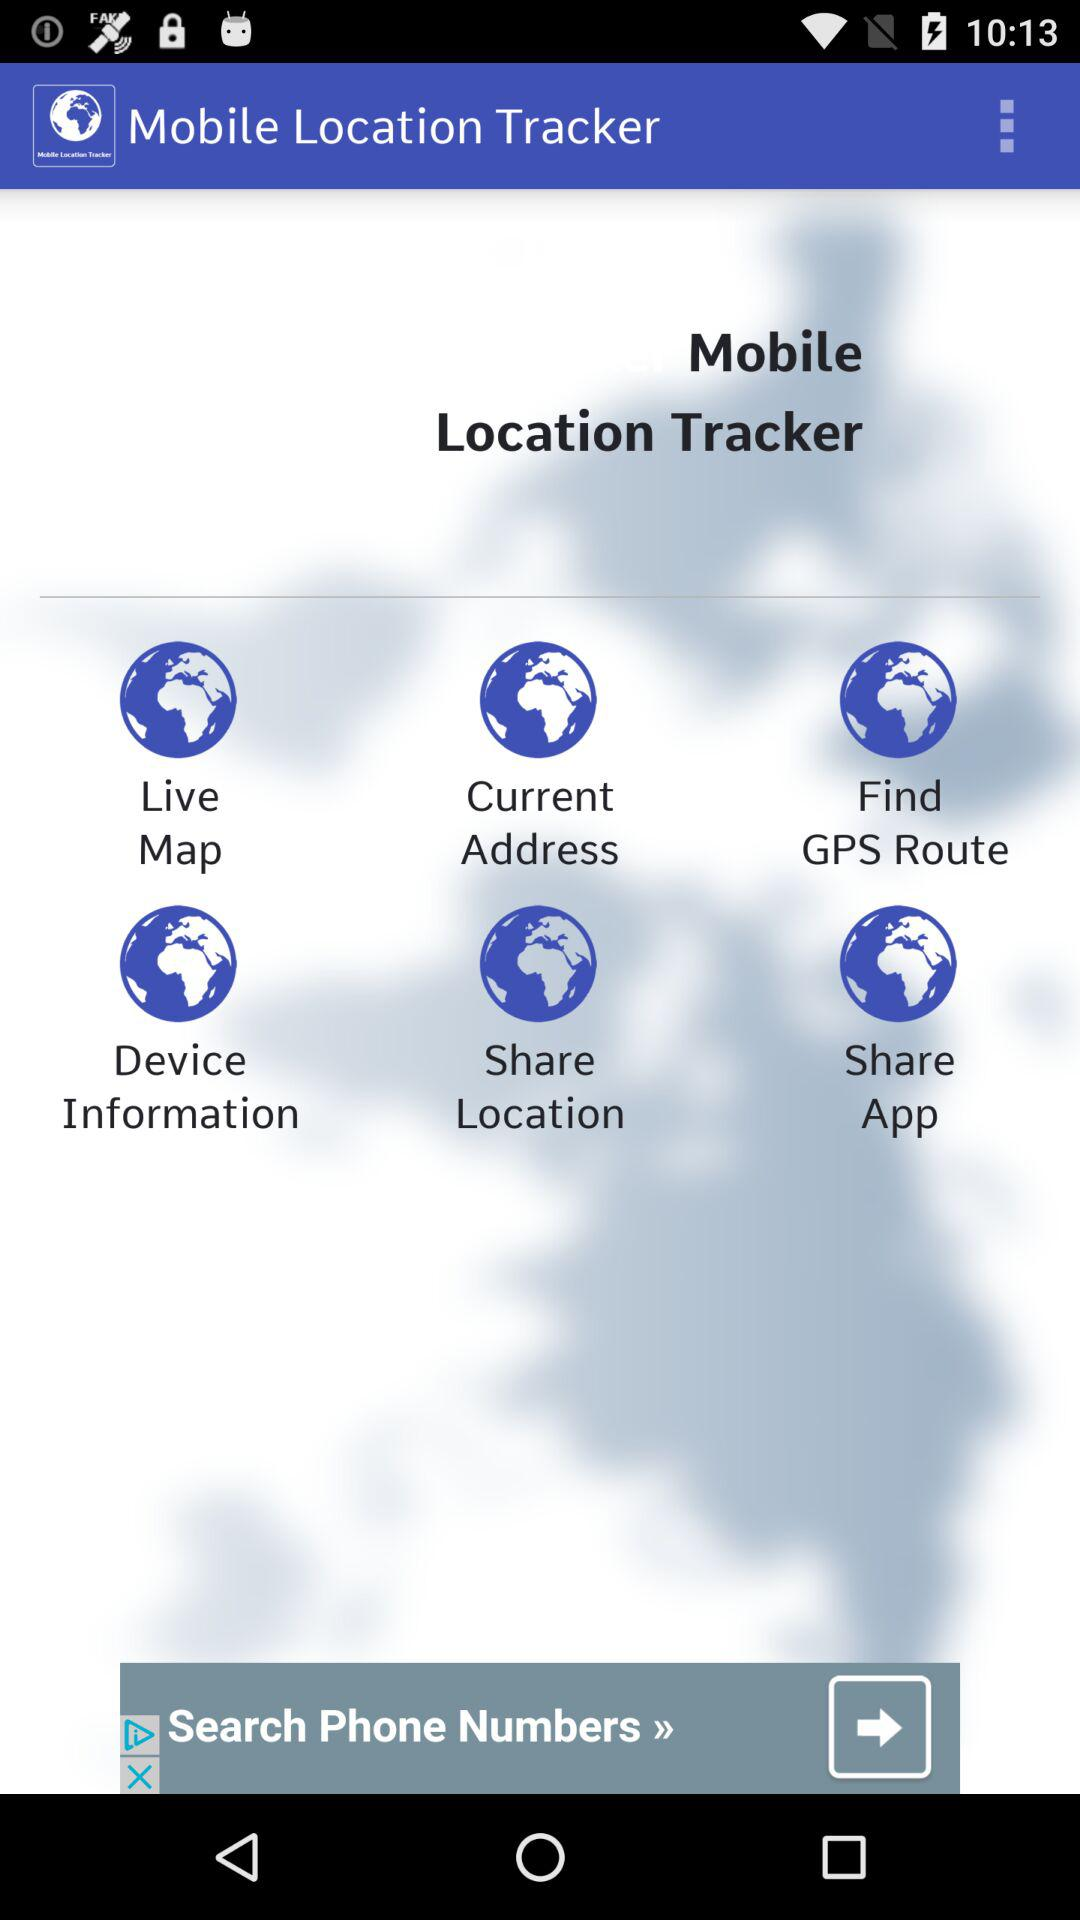What is the application name? The application name is "Mobile Location Tracker". 